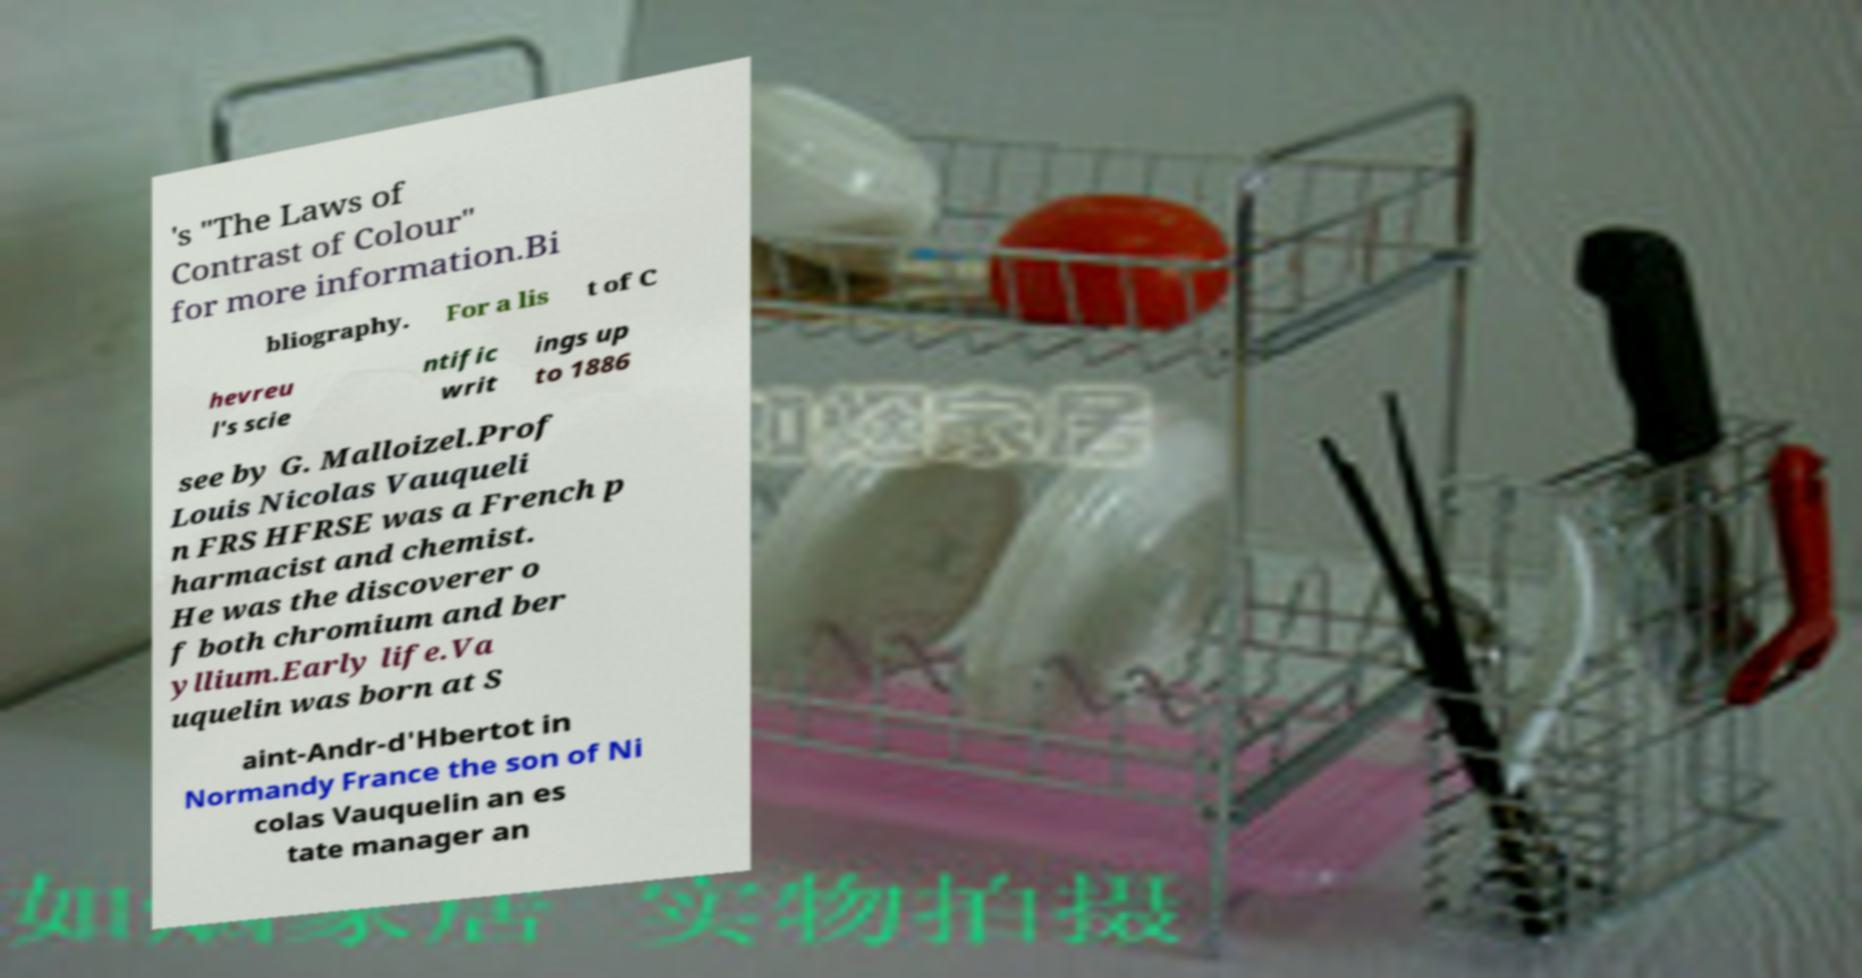Please read and relay the text visible in this image. What does it say? 's "The Laws of Contrast of Colour" for more information.Bi bliography. For a lis t of C hevreu l's scie ntific writ ings up to 1886 see by G. Malloizel.Prof Louis Nicolas Vauqueli n FRS HFRSE was a French p harmacist and chemist. He was the discoverer o f both chromium and ber yllium.Early life.Va uquelin was born at S aint-Andr-d'Hbertot in Normandy France the son of Ni colas Vauquelin an es tate manager an 